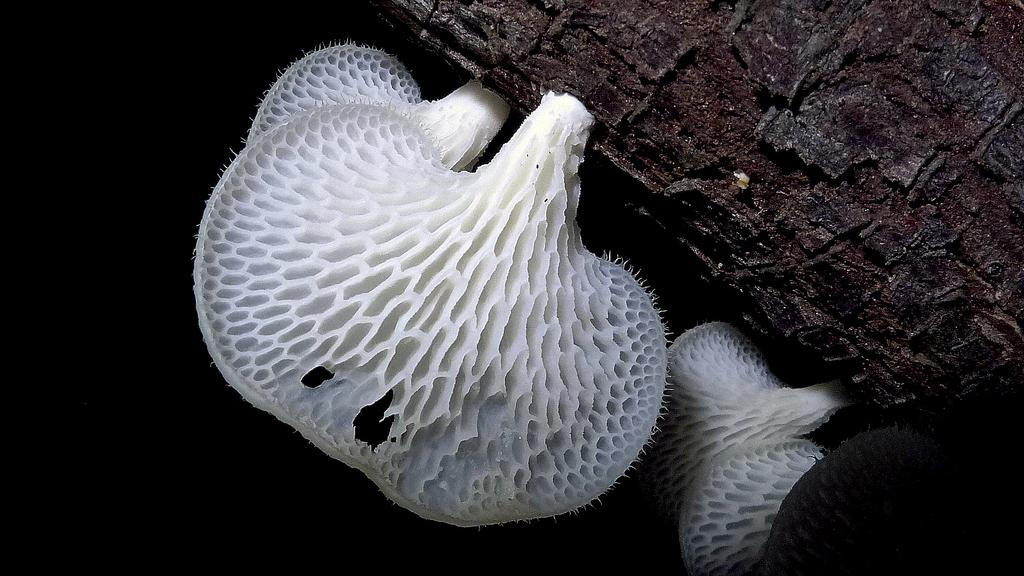What type of fungi can be seen in the image? There are mushrooms in the image. Where are the mushrooms located? The mushrooms are growing on a tree trunk. What type of gate is present in the image? There is no gate present in the image; it features mushrooms growing on a tree trunk. What treatment is being administered to the mushrooms in the image? There is no treatment being administered to the mushrooms in the image; they are simply growing on the tree trunk. 